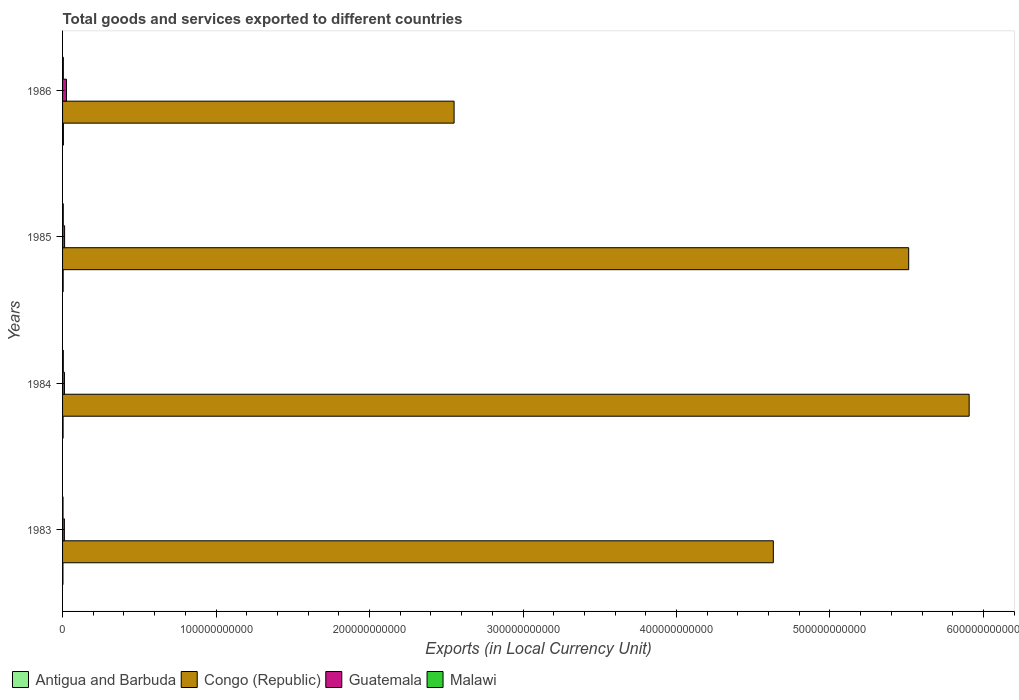How many bars are there on the 3rd tick from the top?
Your response must be concise. 4. How many bars are there on the 2nd tick from the bottom?
Provide a succinct answer. 4. In how many cases, is the number of bars for a given year not equal to the number of legend labels?
Give a very brief answer. 0. What is the Amount of goods and services exports in Antigua and Barbuda in 1985?
Offer a terse response. 4.10e+08. Across all years, what is the maximum Amount of goods and services exports in Malawi?
Your answer should be compact. 5.05e+08. Across all years, what is the minimum Amount of goods and services exports in Congo (Republic)?
Offer a very short reply. 2.55e+11. In which year was the Amount of goods and services exports in Congo (Republic) maximum?
Your answer should be compact. 1984. In which year was the Amount of goods and services exports in Guatemala minimum?
Offer a terse response. 1983. What is the total Amount of goods and services exports in Antigua and Barbuda in the graph?
Your answer should be compact. 1.57e+09. What is the difference between the Amount of goods and services exports in Guatemala in 1983 and that in 1986?
Offer a very short reply. -1.37e+09. What is the difference between the Amount of goods and services exports in Congo (Republic) in 1983 and the Amount of goods and services exports in Antigua and Barbuda in 1986?
Provide a short and direct response. 4.63e+11. What is the average Amount of goods and services exports in Malawi per year?
Provide a succinct answer. 4.39e+08. In the year 1983, what is the difference between the Amount of goods and services exports in Congo (Republic) and Amount of goods and services exports in Antigua and Barbuda?
Keep it short and to the point. 4.63e+11. What is the ratio of the Amount of goods and services exports in Malawi in 1984 to that in 1986?
Your answer should be compact. 0.96. What is the difference between the highest and the second highest Amount of goods and services exports in Malawi?
Offer a terse response. 2.03e+07. What is the difference between the highest and the lowest Amount of goods and services exports in Guatemala?
Your answer should be compact. 1.37e+09. In how many years, is the Amount of goods and services exports in Malawi greater than the average Amount of goods and services exports in Malawi taken over all years?
Make the answer very short. 3. What does the 3rd bar from the top in 1984 represents?
Provide a short and direct response. Congo (Republic). What does the 3rd bar from the bottom in 1985 represents?
Make the answer very short. Guatemala. Is it the case that in every year, the sum of the Amount of goods and services exports in Malawi and Amount of goods and services exports in Antigua and Barbuda is greater than the Amount of goods and services exports in Guatemala?
Provide a succinct answer. No. How many years are there in the graph?
Offer a terse response. 4. What is the difference between two consecutive major ticks on the X-axis?
Offer a very short reply. 1.00e+11. Does the graph contain any zero values?
Keep it short and to the point. No. Where does the legend appear in the graph?
Your answer should be compact. Bottom left. How many legend labels are there?
Keep it short and to the point. 4. How are the legend labels stacked?
Ensure brevity in your answer.  Horizontal. What is the title of the graph?
Keep it short and to the point. Total goods and services exported to different countries. What is the label or title of the X-axis?
Make the answer very short. Exports (in Local Currency Unit). What is the Exports (in Local Currency Unit) of Antigua and Barbuda in 1983?
Your answer should be compact. 2.54e+08. What is the Exports (in Local Currency Unit) of Congo (Republic) in 1983?
Your answer should be compact. 4.63e+11. What is the Exports (in Local Currency Unit) of Guatemala in 1983?
Ensure brevity in your answer.  1.18e+09. What is the Exports (in Local Currency Unit) in Malawi in 1983?
Ensure brevity in your answer.  2.98e+08. What is the Exports (in Local Currency Unit) in Antigua and Barbuda in 1984?
Your response must be concise. 3.50e+08. What is the Exports (in Local Currency Unit) in Congo (Republic) in 1984?
Provide a short and direct response. 5.91e+11. What is the Exports (in Local Currency Unit) of Guatemala in 1984?
Your answer should be very brief. 1.23e+09. What is the Exports (in Local Currency Unit) of Malawi in 1984?
Keep it short and to the point. 4.84e+08. What is the Exports (in Local Currency Unit) of Antigua and Barbuda in 1985?
Offer a terse response. 4.10e+08. What is the Exports (in Local Currency Unit) of Congo (Republic) in 1985?
Offer a very short reply. 5.51e+11. What is the Exports (in Local Currency Unit) of Guatemala in 1985?
Keep it short and to the point. 1.34e+09. What is the Exports (in Local Currency Unit) of Malawi in 1985?
Provide a succinct answer. 4.70e+08. What is the Exports (in Local Currency Unit) of Antigua and Barbuda in 1986?
Give a very brief answer. 5.58e+08. What is the Exports (in Local Currency Unit) in Congo (Republic) in 1986?
Make the answer very short. 2.55e+11. What is the Exports (in Local Currency Unit) in Guatemala in 1986?
Keep it short and to the point. 2.54e+09. What is the Exports (in Local Currency Unit) of Malawi in 1986?
Provide a succinct answer. 5.05e+08. Across all years, what is the maximum Exports (in Local Currency Unit) in Antigua and Barbuda?
Provide a short and direct response. 5.58e+08. Across all years, what is the maximum Exports (in Local Currency Unit) of Congo (Republic)?
Provide a short and direct response. 5.91e+11. Across all years, what is the maximum Exports (in Local Currency Unit) of Guatemala?
Make the answer very short. 2.54e+09. Across all years, what is the maximum Exports (in Local Currency Unit) in Malawi?
Keep it short and to the point. 5.05e+08. Across all years, what is the minimum Exports (in Local Currency Unit) of Antigua and Barbuda?
Give a very brief answer. 2.54e+08. Across all years, what is the minimum Exports (in Local Currency Unit) of Congo (Republic)?
Provide a short and direct response. 2.55e+11. Across all years, what is the minimum Exports (in Local Currency Unit) of Guatemala?
Offer a very short reply. 1.18e+09. Across all years, what is the minimum Exports (in Local Currency Unit) of Malawi?
Keep it short and to the point. 2.98e+08. What is the total Exports (in Local Currency Unit) of Antigua and Barbuda in the graph?
Offer a very short reply. 1.57e+09. What is the total Exports (in Local Currency Unit) in Congo (Republic) in the graph?
Keep it short and to the point. 1.86e+12. What is the total Exports (in Local Currency Unit) of Guatemala in the graph?
Give a very brief answer. 6.29e+09. What is the total Exports (in Local Currency Unit) in Malawi in the graph?
Offer a terse response. 1.76e+09. What is the difference between the Exports (in Local Currency Unit) of Antigua and Barbuda in 1983 and that in 1984?
Keep it short and to the point. -9.63e+07. What is the difference between the Exports (in Local Currency Unit) in Congo (Republic) in 1983 and that in 1984?
Your answer should be very brief. -1.28e+11. What is the difference between the Exports (in Local Currency Unit) of Guatemala in 1983 and that in 1984?
Ensure brevity in your answer.  -5.53e+07. What is the difference between the Exports (in Local Currency Unit) of Malawi in 1983 and that in 1984?
Give a very brief answer. -1.86e+08. What is the difference between the Exports (in Local Currency Unit) of Antigua and Barbuda in 1983 and that in 1985?
Provide a short and direct response. -1.56e+08. What is the difference between the Exports (in Local Currency Unit) of Congo (Republic) in 1983 and that in 1985?
Make the answer very short. -8.82e+1. What is the difference between the Exports (in Local Currency Unit) of Guatemala in 1983 and that in 1985?
Your response must be concise. -1.60e+08. What is the difference between the Exports (in Local Currency Unit) in Malawi in 1983 and that in 1985?
Your response must be concise. -1.72e+08. What is the difference between the Exports (in Local Currency Unit) in Antigua and Barbuda in 1983 and that in 1986?
Your answer should be very brief. -3.05e+08. What is the difference between the Exports (in Local Currency Unit) of Congo (Republic) in 1983 and that in 1986?
Make the answer very short. 2.08e+11. What is the difference between the Exports (in Local Currency Unit) of Guatemala in 1983 and that in 1986?
Provide a short and direct response. -1.37e+09. What is the difference between the Exports (in Local Currency Unit) of Malawi in 1983 and that in 1986?
Ensure brevity in your answer.  -2.06e+08. What is the difference between the Exports (in Local Currency Unit) of Antigua and Barbuda in 1984 and that in 1985?
Your response must be concise. -5.94e+07. What is the difference between the Exports (in Local Currency Unit) in Congo (Republic) in 1984 and that in 1985?
Offer a very short reply. 3.94e+1. What is the difference between the Exports (in Local Currency Unit) of Guatemala in 1984 and that in 1985?
Your response must be concise. -1.05e+08. What is the difference between the Exports (in Local Currency Unit) in Malawi in 1984 and that in 1985?
Offer a very short reply. 1.39e+07. What is the difference between the Exports (in Local Currency Unit) in Antigua and Barbuda in 1984 and that in 1986?
Give a very brief answer. -2.08e+08. What is the difference between the Exports (in Local Currency Unit) of Congo (Republic) in 1984 and that in 1986?
Offer a very short reply. 3.36e+11. What is the difference between the Exports (in Local Currency Unit) in Guatemala in 1984 and that in 1986?
Give a very brief answer. -1.31e+09. What is the difference between the Exports (in Local Currency Unit) of Malawi in 1984 and that in 1986?
Provide a succinct answer. -2.03e+07. What is the difference between the Exports (in Local Currency Unit) of Antigua and Barbuda in 1985 and that in 1986?
Provide a succinct answer. -1.49e+08. What is the difference between the Exports (in Local Currency Unit) in Congo (Republic) in 1985 and that in 1986?
Provide a succinct answer. 2.96e+11. What is the difference between the Exports (in Local Currency Unit) of Guatemala in 1985 and that in 1986?
Give a very brief answer. -1.21e+09. What is the difference between the Exports (in Local Currency Unit) of Malawi in 1985 and that in 1986?
Your answer should be very brief. -3.42e+07. What is the difference between the Exports (in Local Currency Unit) of Antigua and Barbuda in 1983 and the Exports (in Local Currency Unit) of Congo (Republic) in 1984?
Offer a terse response. -5.90e+11. What is the difference between the Exports (in Local Currency Unit) in Antigua and Barbuda in 1983 and the Exports (in Local Currency Unit) in Guatemala in 1984?
Offer a very short reply. -9.77e+08. What is the difference between the Exports (in Local Currency Unit) of Antigua and Barbuda in 1983 and the Exports (in Local Currency Unit) of Malawi in 1984?
Keep it short and to the point. -2.31e+08. What is the difference between the Exports (in Local Currency Unit) of Congo (Republic) in 1983 and the Exports (in Local Currency Unit) of Guatemala in 1984?
Offer a terse response. 4.62e+11. What is the difference between the Exports (in Local Currency Unit) of Congo (Republic) in 1983 and the Exports (in Local Currency Unit) of Malawi in 1984?
Ensure brevity in your answer.  4.63e+11. What is the difference between the Exports (in Local Currency Unit) in Guatemala in 1983 and the Exports (in Local Currency Unit) in Malawi in 1984?
Your answer should be compact. 6.92e+08. What is the difference between the Exports (in Local Currency Unit) in Antigua and Barbuda in 1983 and the Exports (in Local Currency Unit) in Congo (Republic) in 1985?
Keep it short and to the point. -5.51e+11. What is the difference between the Exports (in Local Currency Unit) of Antigua and Barbuda in 1983 and the Exports (in Local Currency Unit) of Guatemala in 1985?
Keep it short and to the point. -1.08e+09. What is the difference between the Exports (in Local Currency Unit) of Antigua and Barbuda in 1983 and the Exports (in Local Currency Unit) of Malawi in 1985?
Your answer should be compact. -2.17e+08. What is the difference between the Exports (in Local Currency Unit) of Congo (Republic) in 1983 and the Exports (in Local Currency Unit) of Guatemala in 1985?
Provide a short and direct response. 4.62e+11. What is the difference between the Exports (in Local Currency Unit) of Congo (Republic) in 1983 and the Exports (in Local Currency Unit) of Malawi in 1985?
Provide a succinct answer. 4.63e+11. What is the difference between the Exports (in Local Currency Unit) in Guatemala in 1983 and the Exports (in Local Currency Unit) in Malawi in 1985?
Keep it short and to the point. 7.06e+08. What is the difference between the Exports (in Local Currency Unit) of Antigua and Barbuda in 1983 and the Exports (in Local Currency Unit) of Congo (Republic) in 1986?
Your response must be concise. -2.55e+11. What is the difference between the Exports (in Local Currency Unit) in Antigua and Barbuda in 1983 and the Exports (in Local Currency Unit) in Guatemala in 1986?
Offer a terse response. -2.29e+09. What is the difference between the Exports (in Local Currency Unit) of Antigua and Barbuda in 1983 and the Exports (in Local Currency Unit) of Malawi in 1986?
Offer a very short reply. -2.51e+08. What is the difference between the Exports (in Local Currency Unit) of Congo (Republic) in 1983 and the Exports (in Local Currency Unit) of Guatemala in 1986?
Offer a very short reply. 4.61e+11. What is the difference between the Exports (in Local Currency Unit) in Congo (Republic) in 1983 and the Exports (in Local Currency Unit) in Malawi in 1986?
Make the answer very short. 4.63e+11. What is the difference between the Exports (in Local Currency Unit) of Guatemala in 1983 and the Exports (in Local Currency Unit) of Malawi in 1986?
Provide a succinct answer. 6.71e+08. What is the difference between the Exports (in Local Currency Unit) of Antigua and Barbuda in 1984 and the Exports (in Local Currency Unit) of Congo (Republic) in 1985?
Provide a short and direct response. -5.51e+11. What is the difference between the Exports (in Local Currency Unit) in Antigua and Barbuda in 1984 and the Exports (in Local Currency Unit) in Guatemala in 1985?
Provide a succinct answer. -9.86e+08. What is the difference between the Exports (in Local Currency Unit) in Antigua and Barbuda in 1984 and the Exports (in Local Currency Unit) in Malawi in 1985?
Your response must be concise. -1.20e+08. What is the difference between the Exports (in Local Currency Unit) in Congo (Republic) in 1984 and the Exports (in Local Currency Unit) in Guatemala in 1985?
Provide a succinct answer. 5.89e+11. What is the difference between the Exports (in Local Currency Unit) of Congo (Republic) in 1984 and the Exports (in Local Currency Unit) of Malawi in 1985?
Provide a succinct answer. 5.90e+11. What is the difference between the Exports (in Local Currency Unit) in Guatemala in 1984 and the Exports (in Local Currency Unit) in Malawi in 1985?
Ensure brevity in your answer.  7.61e+08. What is the difference between the Exports (in Local Currency Unit) in Antigua and Barbuda in 1984 and the Exports (in Local Currency Unit) in Congo (Republic) in 1986?
Your answer should be very brief. -2.55e+11. What is the difference between the Exports (in Local Currency Unit) of Antigua and Barbuda in 1984 and the Exports (in Local Currency Unit) of Guatemala in 1986?
Keep it short and to the point. -2.19e+09. What is the difference between the Exports (in Local Currency Unit) of Antigua and Barbuda in 1984 and the Exports (in Local Currency Unit) of Malawi in 1986?
Ensure brevity in your answer.  -1.55e+08. What is the difference between the Exports (in Local Currency Unit) in Congo (Republic) in 1984 and the Exports (in Local Currency Unit) in Guatemala in 1986?
Your answer should be very brief. 5.88e+11. What is the difference between the Exports (in Local Currency Unit) in Congo (Republic) in 1984 and the Exports (in Local Currency Unit) in Malawi in 1986?
Make the answer very short. 5.90e+11. What is the difference between the Exports (in Local Currency Unit) of Guatemala in 1984 and the Exports (in Local Currency Unit) of Malawi in 1986?
Your answer should be compact. 7.27e+08. What is the difference between the Exports (in Local Currency Unit) of Antigua and Barbuda in 1985 and the Exports (in Local Currency Unit) of Congo (Republic) in 1986?
Your answer should be very brief. -2.55e+11. What is the difference between the Exports (in Local Currency Unit) in Antigua and Barbuda in 1985 and the Exports (in Local Currency Unit) in Guatemala in 1986?
Provide a short and direct response. -2.13e+09. What is the difference between the Exports (in Local Currency Unit) of Antigua and Barbuda in 1985 and the Exports (in Local Currency Unit) of Malawi in 1986?
Provide a short and direct response. -9.52e+07. What is the difference between the Exports (in Local Currency Unit) in Congo (Republic) in 1985 and the Exports (in Local Currency Unit) in Guatemala in 1986?
Offer a very short reply. 5.49e+11. What is the difference between the Exports (in Local Currency Unit) of Congo (Republic) in 1985 and the Exports (in Local Currency Unit) of Malawi in 1986?
Provide a short and direct response. 5.51e+11. What is the difference between the Exports (in Local Currency Unit) in Guatemala in 1985 and the Exports (in Local Currency Unit) in Malawi in 1986?
Make the answer very short. 8.31e+08. What is the average Exports (in Local Currency Unit) of Antigua and Barbuda per year?
Your response must be concise. 3.93e+08. What is the average Exports (in Local Currency Unit) in Congo (Republic) per year?
Ensure brevity in your answer.  4.65e+11. What is the average Exports (in Local Currency Unit) in Guatemala per year?
Your response must be concise. 1.57e+09. What is the average Exports (in Local Currency Unit) in Malawi per year?
Keep it short and to the point. 4.39e+08. In the year 1983, what is the difference between the Exports (in Local Currency Unit) of Antigua and Barbuda and Exports (in Local Currency Unit) of Congo (Republic)?
Provide a succinct answer. -4.63e+11. In the year 1983, what is the difference between the Exports (in Local Currency Unit) of Antigua and Barbuda and Exports (in Local Currency Unit) of Guatemala?
Offer a terse response. -9.22e+08. In the year 1983, what is the difference between the Exports (in Local Currency Unit) of Antigua and Barbuda and Exports (in Local Currency Unit) of Malawi?
Give a very brief answer. -4.43e+07. In the year 1983, what is the difference between the Exports (in Local Currency Unit) in Congo (Republic) and Exports (in Local Currency Unit) in Guatemala?
Provide a succinct answer. 4.62e+11. In the year 1983, what is the difference between the Exports (in Local Currency Unit) in Congo (Republic) and Exports (in Local Currency Unit) in Malawi?
Offer a very short reply. 4.63e+11. In the year 1983, what is the difference between the Exports (in Local Currency Unit) in Guatemala and Exports (in Local Currency Unit) in Malawi?
Your answer should be very brief. 8.78e+08. In the year 1984, what is the difference between the Exports (in Local Currency Unit) of Antigua and Barbuda and Exports (in Local Currency Unit) of Congo (Republic)?
Your answer should be compact. -5.90e+11. In the year 1984, what is the difference between the Exports (in Local Currency Unit) of Antigua and Barbuda and Exports (in Local Currency Unit) of Guatemala?
Offer a very short reply. -8.81e+08. In the year 1984, what is the difference between the Exports (in Local Currency Unit) of Antigua and Barbuda and Exports (in Local Currency Unit) of Malawi?
Your response must be concise. -1.34e+08. In the year 1984, what is the difference between the Exports (in Local Currency Unit) in Congo (Republic) and Exports (in Local Currency Unit) in Guatemala?
Your answer should be very brief. 5.89e+11. In the year 1984, what is the difference between the Exports (in Local Currency Unit) in Congo (Republic) and Exports (in Local Currency Unit) in Malawi?
Offer a very short reply. 5.90e+11. In the year 1984, what is the difference between the Exports (in Local Currency Unit) in Guatemala and Exports (in Local Currency Unit) in Malawi?
Offer a very short reply. 7.47e+08. In the year 1985, what is the difference between the Exports (in Local Currency Unit) in Antigua and Barbuda and Exports (in Local Currency Unit) in Congo (Republic)?
Your response must be concise. -5.51e+11. In the year 1985, what is the difference between the Exports (in Local Currency Unit) in Antigua and Barbuda and Exports (in Local Currency Unit) in Guatemala?
Provide a succinct answer. -9.26e+08. In the year 1985, what is the difference between the Exports (in Local Currency Unit) of Antigua and Barbuda and Exports (in Local Currency Unit) of Malawi?
Your response must be concise. -6.10e+07. In the year 1985, what is the difference between the Exports (in Local Currency Unit) of Congo (Republic) and Exports (in Local Currency Unit) of Guatemala?
Provide a short and direct response. 5.50e+11. In the year 1985, what is the difference between the Exports (in Local Currency Unit) in Congo (Republic) and Exports (in Local Currency Unit) in Malawi?
Provide a succinct answer. 5.51e+11. In the year 1985, what is the difference between the Exports (in Local Currency Unit) in Guatemala and Exports (in Local Currency Unit) in Malawi?
Provide a short and direct response. 8.65e+08. In the year 1986, what is the difference between the Exports (in Local Currency Unit) in Antigua and Barbuda and Exports (in Local Currency Unit) in Congo (Republic)?
Your answer should be compact. -2.55e+11. In the year 1986, what is the difference between the Exports (in Local Currency Unit) of Antigua and Barbuda and Exports (in Local Currency Unit) of Guatemala?
Ensure brevity in your answer.  -1.98e+09. In the year 1986, what is the difference between the Exports (in Local Currency Unit) in Antigua and Barbuda and Exports (in Local Currency Unit) in Malawi?
Ensure brevity in your answer.  5.38e+07. In the year 1986, what is the difference between the Exports (in Local Currency Unit) in Congo (Republic) and Exports (in Local Currency Unit) in Guatemala?
Provide a succinct answer. 2.53e+11. In the year 1986, what is the difference between the Exports (in Local Currency Unit) in Congo (Republic) and Exports (in Local Currency Unit) in Malawi?
Make the answer very short. 2.55e+11. In the year 1986, what is the difference between the Exports (in Local Currency Unit) of Guatemala and Exports (in Local Currency Unit) of Malawi?
Provide a succinct answer. 2.04e+09. What is the ratio of the Exports (in Local Currency Unit) in Antigua and Barbuda in 1983 to that in 1984?
Make the answer very short. 0.72. What is the ratio of the Exports (in Local Currency Unit) of Congo (Republic) in 1983 to that in 1984?
Provide a succinct answer. 0.78. What is the ratio of the Exports (in Local Currency Unit) in Guatemala in 1983 to that in 1984?
Make the answer very short. 0.96. What is the ratio of the Exports (in Local Currency Unit) of Malawi in 1983 to that in 1984?
Offer a terse response. 0.62. What is the ratio of the Exports (in Local Currency Unit) of Antigua and Barbuda in 1983 to that in 1985?
Keep it short and to the point. 0.62. What is the ratio of the Exports (in Local Currency Unit) in Congo (Republic) in 1983 to that in 1985?
Make the answer very short. 0.84. What is the ratio of the Exports (in Local Currency Unit) in Guatemala in 1983 to that in 1985?
Provide a short and direct response. 0.88. What is the ratio of the Exports (in Local Currency Unit) of Malawi in 1983 to that in 1985?
Provide a short and direct response. 0.63. What is the ratio of the Exports (in Local Currency Unit) in Antigua and Barbuda in 1983 to that in 1986?
Offer a terse response. 0.45. What is the ratio of the Exports (in Local Currency Unit) of Congo (Republic) in 1983 to that in 1986?
Make the answer very short. 1.82. What is the ratio of the Exports (in Local Currency Unit) in Guatemala in 1983 to that in 1986?
Offer a very short reply. 0.46. What is the ratio of the Exports (in Local Currency Unit) of Malawi in 1983 to that in 1986?
Your response must be concise. 0.59. What is the ratio of the Exports (in Local Currency Unit) of Antigua and Barbuda in 1984 to that in 1985?
Your answer should be very brief. 0.85. What is the ratio of the Exports (in Local Currency Unit) of Congo (Republic) in 1984 to that in 1985?
Offer a terse response. 1.07. What is the ratio of the Exports (in Local Currency Unit) of Guatemala in 1984 to that in 1985?
Offer a very short reply. 0.92. What is the ratio of the Exports (in Local Currency Unit) in Malawi in 1984 to that in 1985?
Keep it short and to the point. 1.03. What is the ratio of the Exports (in Local Currency Unit) in Antigua and Barbuda in 1984 to that in 1986?
Provide a short and direct response. 0.63. What is the ratio of the Exports (in Local Currency Unit) in Congo (Republic) in 1984 to that in 1986?
Give a very brief answer. 2.32. What is the ratio of the Exports (in Local Currency Unit) in Guatemala in 1984 to that in 1986?
Your answer should be compact. 0.48. What is the ratio of the Exports (in Local Currency Unit) in Malawi in 1984 to that in 1986?
Provide a short and direct response. 0.96. What is the ratio of the Exports (in Local Currency Unit) in Antigua and Barbuda in 1985 to that in 1986?
Your response must be concise. 0.73. What is the ratio of the Exports (in Local Currency Unit) in Congo (Republic) in 1985 to that in 1986?
Offer a terse response. 2.16. What is the ratio of the Exports (in Local Currency Unit) of Guatemala in 1985 to that in 1986?
Provide a short and direct response. 0.53. What is the ratio of the Exports (in Local Currency Unit) in Malawi in 1985 to that in 1986?
Keep it short and to the point. 0.93. What is the difference between the highest and the second highest Exports (in Local Currency Unit) of Antigua and Barbuda?
Keep it short and to the point. 1.49e+08. What is the difference between the highest and the second highest Exports (in Local Currency Unit) of Congo (Republic)?
Your answer should be compact. 3.94e+1. What is the difference between the highest and the second highest Exports (in Local Currency Unit) in Guatemala?
Provide a short and direct response. 1.21e+09. What is the difference between the highest and the second highest Exports (in Local Currency Unit) in Malawi?
Your response must be concise. 2.03e+07. What is the difference between the highest and the lowest Exports (in Local Currency Unit) of Antigua and Barbuda?
Give a very brief answer. 3.05e+08. What is the difference between the highest and the lowest Exports (in Local Currency Unit) of Congo (Republic)?
Provide a short and direct response. 3.36e+11. What is the difference between the highest and the lowest Exports (in Local Currency Unit) in Guatemala?
Give a very brief answer. 1.37e+09. What is the difference between the highest and the lowest Exports (in Local Currency Unit) in Malawi?
Keep it short and to the point. 2.06e+08. 